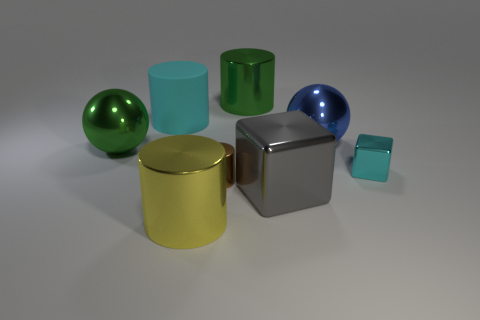Is there any other thing that is the same material as the big cyan thing?
Make the answer very short. No. There is a ball on the right side of the cyan cylinder; does it have the same size as the small block?
Offer a terse response. No. Are there any other things that are the same color as the large cube?
Your answer should be very brief. No. The metallic object that is both behind the green ball and left of the blue shiny ball has what shape?
Provide a succinct answer. Cylinder. Is the number of objects in front of the small metallic cylinder the same as the number of cylinders in front of the big green ball?
Your answer should be very brief. Yes. What number of blocks are either small objects or brown objects?
Provide a succinct answer. 1. How many large cylinders have the same material as the tiny brown cylinder?
Offer a very short reply. 2. What shape is the small shiny thing that is the same color as the large matte object?
Give a very brief answer. Cube. What material is the big thing that is behind the big blue ball and on the left side of the yellow metal object?
Keep it short and to the point. Rubber. The green thing left of the brown cylinder has what shape?
Offer a terse response. Sphere. 